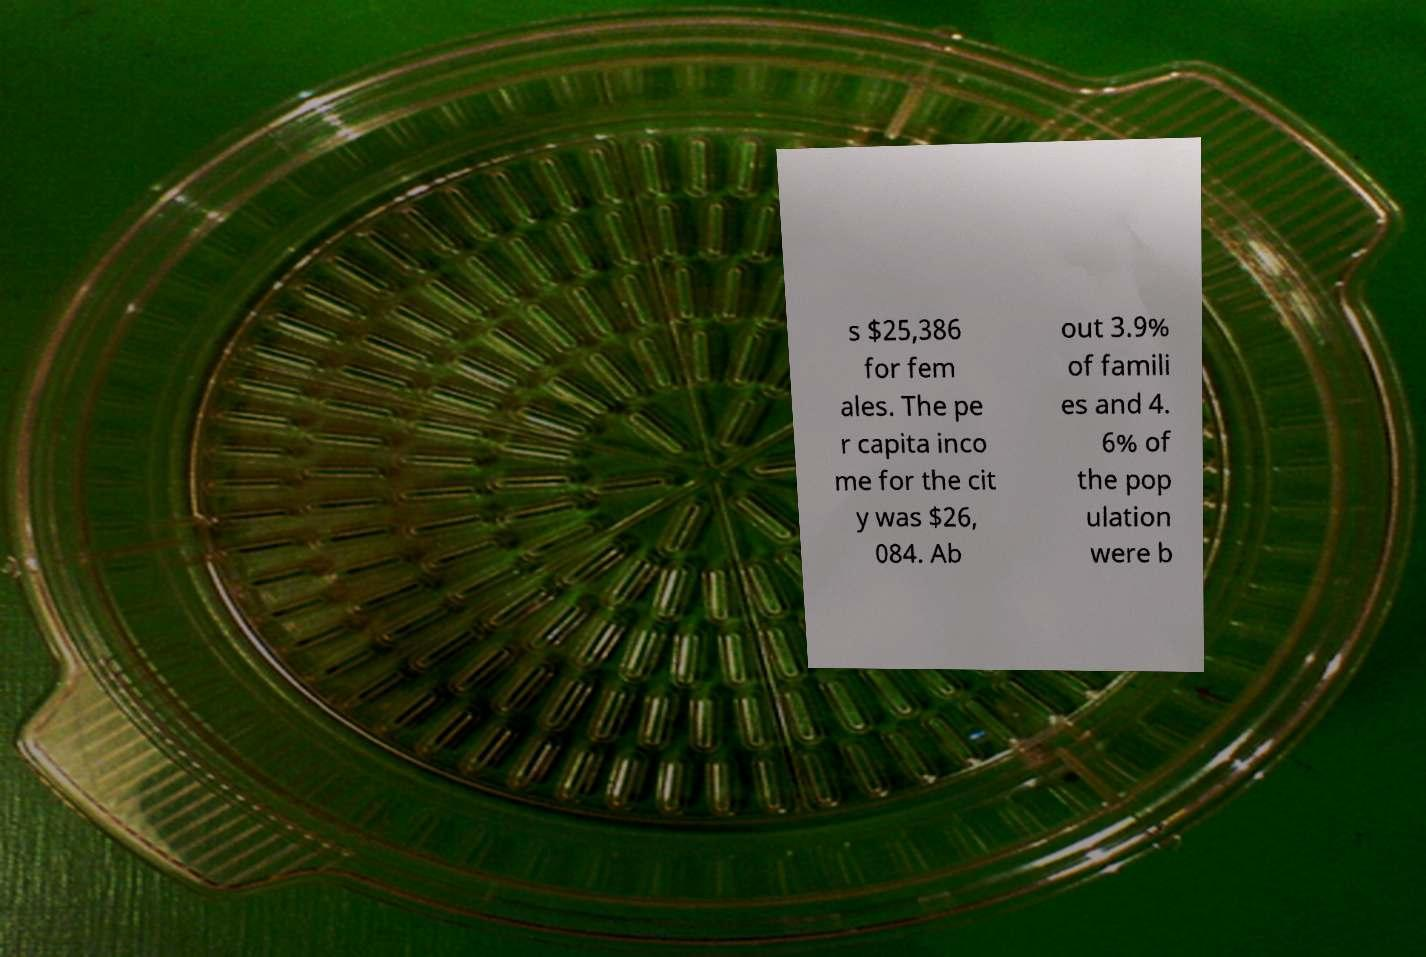For documentation purposes, I need the text within this image transcribed. Could you provide that? s $25,386 for fem ales. The pe r capita inco me for the cit y was $26, 084. Ab out 3.9% of famili es and 4. 6% of the pop ulation were b 